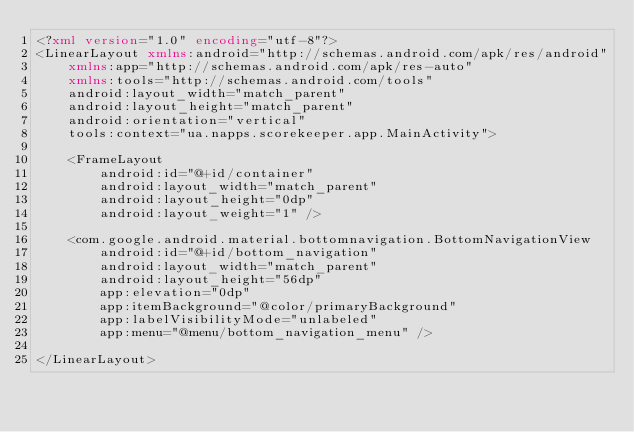Convert code to text. <code><loc_0><loc_0><loc_500><loc_500><_XML_><?xml version="1.0" encoding="utf-8"?>
<LinearLayout xmlns:android="http://schemas.android.com/apk/res/android"
    xmlns:app="http://schemas.android.com/apk/res-auto"
    xmlns:tools="http://schemas.android.com/tools"
    android:layout_width="match_parent"
    android:layout_height="match_parent"
    android:orientation="vertical"
    tools:context="ua.napps.scorekeeper.app.MainActivity">

    <FrameLayout
        android:id="@+id/container"
        android:layout_width="match_parent"
        android:layout_height="0dp"
        android:layout_weight="1" />

    <com.google.android.material.bottomnavigation.BottomNavigationView
        android:id="@+id/bottom_navigation"
        android:layout_width="match_parent"
        android:layout_height="56dp"
        app:elevation="0dp"
        app:itemBackground="@color/primaryBackground"
        app:labelVisibilityMode="unlabeled"
        app:menu="@menu/bottom_navigation_menu" />

</LinearLayout></code> 